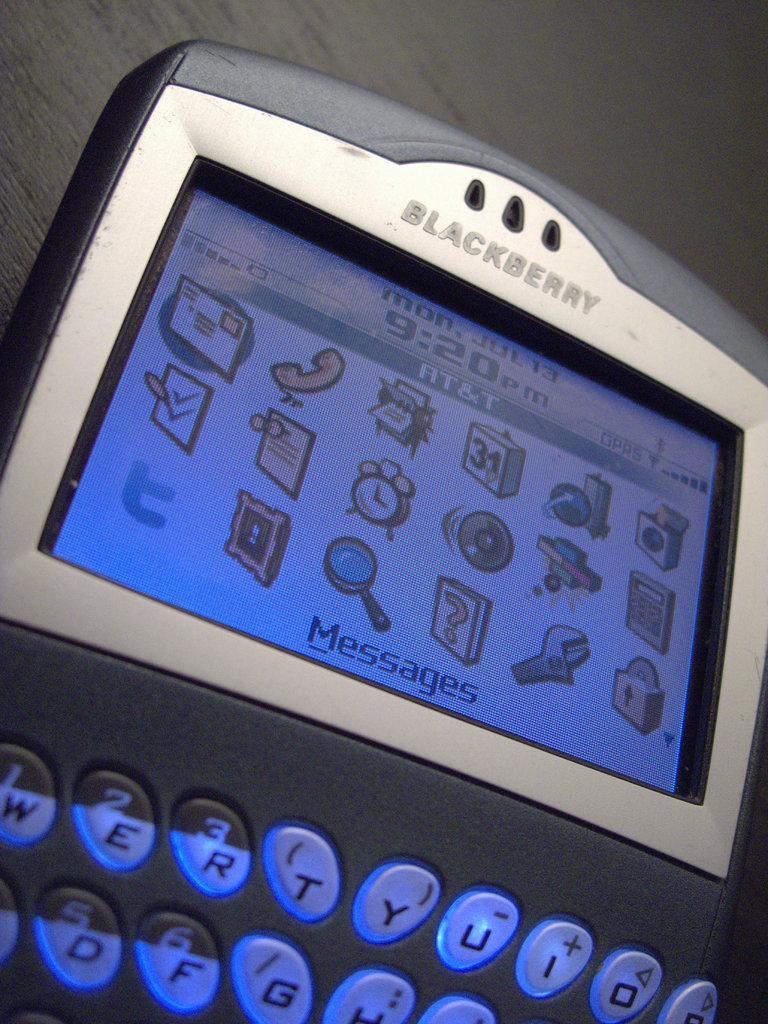Can you describe this image briefly? In this image we can see a mobile placed on the table. 